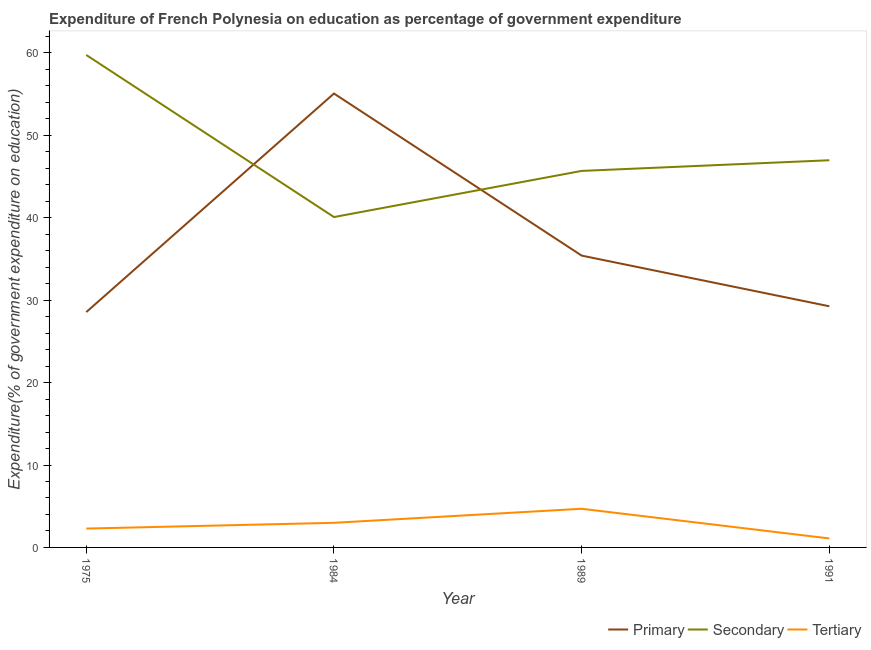What is the expenditure on secondary education in 1989?
Provide a short and direct response. 45.69. Across all years, what is the maximum expenditure on primary education?
Provide a short and direct response. 55.08. Across all years, what is the minimum expenditure on tertiary education?
Your answer should be very brief. 1.09. What is the total expenditure on primary education in the graph?
Your response must be concise. 148.32. What is the difference between the expenditure on tertiary education in 1975 and that in 1984?
Provide a short and direct response. -0.7. What is the difference between the expenditure on secondary education in 1984 and the expenditure on tertiary education in 1975?
Ensure brevity in your answer.  37.8. What is the average expenditure on secondary education per year?
Offer a very short reply. 48.13. In the year 1989, what is the difference between the expenditure on primary education and expenditure on secondary education?
Your answer should be very brief. -10.28. What is the ratio of the expenditure on primary education in 1989 to that in 1991?
Keep it short and to the point. 1.21. Is the expenditure on secondary education in 1984 less than that in 1991?
Keep it short and to the point. Yes. Is the difference between the expenditure on tertiary education in 1989 and 1991 greater than the difference between the expenditure on primary education in 1989 and 1991?
Keep it short and to the point. No. What is the difference between the highest and the second highest expenditure on primary education?
Offer a terse response. 19.67. What is the difference between the highest and the lowest expenditure on primary education?
Ensure brevity in your answer.  26.52. In how many years, is the expenditure on tertiary education greater than the average expenditure on tertiary education taken over all years?
Give a very brief answer. 2. Is the sum of the expenditure on secondary education in 1984 and 1991 greater than the maximum expenditure on primary education across all years?
Provide a succinct answer. Yes. Is it the case that in every year, the sum of the expenditure on primary education and expenditure on secondary education is greater than the expenditure on tertiary education?
Your response must be concise. Yes. How many lines are there?
Offer a very short reply. 3. How many years are there in the graph?
Give a very brief answer. 4. What is the difference between two consecutive major ticks on the Y-axis?
Offer a terse response. 10. Are the values on the major ticks of Y-axis written in scientific E-notation?
Keep it short and to the point. No. Does the graph contain any zero values?
Your answer should be compact. No. Does the graph contain grids?
Offer a very short reply. No. What is the title of the graph?
Give a very brief answer. Expenditure of French Polynesia on education as percentage of government expenditure. What is the label or title of the X-axis?
Provide a succinct answer. Year. What is the label or title of the Y-axis?
Provide a short and direct response. Expenditure(% of government expenditure on education). What is the Expenditure(% of government expenditure on education) in Primary in 1975?
Give a very brief answer. 28.56. What is the Expenditure(% of government expenditure on education) in Secondary in 1975?
Keep it short and to the point. 59.76. What is the Expenditure(% of government expenditure on education) of Tertiary in 1975?
Keep it short and to the point. 2.29. What is the Expenditure(% of government expenditure on education) of Primary in 1984?
Your answer should be very brief. 55.08. What is the Expenditure(% of government expenditure on education) of Secondary in 1984?
Your answer should be very brief. 40.09. What is the Expenditure(% of government expenditure on education) in Tertiary in 1984?
Provide a short and direct response. 2.99. What is the Expenditure(% of government expenditure on education) of Primary in 1989?
Make the answer very short. 35.41. What is the Expenditure(% of government expenditure on education) of Secondary in 1989?
Your response must be concise. 45.69. What is the Expenditure(% of government expenditure on education) of Tertiary in 1989?
Your answer should be compact. 4.69. What is the Expenditure(% of government expenditure on education) in Primary in 1991?
Give a very brief answer. 29.26. What is the Expenditure(% of government expenditure on education) of Secondary in 1991?
Your response must be concise. 46.98. What is the Expenditure(% of government expenditure on education) in Tertiary in 1991?
Your answer should be very brief. 1.09. Across all years, what is the maximum Expenditure(% of government expenditure on education) of Primary?
Provide a succinct answer. 55.08. Across all years, what is the maximum Expenditure(% of government expenditure on education) in Secondary?
Ensure brevity in your answer.  59.76. Across all years, what is the maximum Expenditure(% of government expenditure on education) in Tertiary?
Provide a short and direct response. 4.69. Across all years, what is the minimum Expenditure(% of government expenditure on education) of Primary?
Your response must be concise. 28.56. Across all years, what is the minimum Expenditure(% of government expenditure on education) in Secondary?
Your answer should be very brief. 40.09. Across all years, what is the minimum Expenditure(% of government expenditure on education) of Tertiary?
Your answer should be very brief. 1.09. What is the total Expenditure(% of government expenditure on education) in Primary in the graph?
Keep it short and to the point. 148.32. What is the total Expenditure(% of government expenditure on education) in Secondary in the graph?
Offer a terse response. 192.52. What is the total Expenditure(% of government expenditure on education) of Tertiary in the graph?
Your response must be concise. 11.06. What is the difference between the Expenditure(% of government expenditure on education) in Primary in 1975 and that in 1984?
Make the answer very short. -26.52. What is the difference between the Expenditure(% of government expenditure on education) of Secondary in 1975 and that in 1984?
Your answer should be compact. 19.66. What is the difference between the Expenditure(% of government expenditure on education) of Tertiary in 1975 and that in 1984?
Provide a succinct answer. -0.7. What is the difference between the Expenditure(% of government expenditure on education) in Primary in 1975 and that in 1989?
Offer a terse response. -6.85. What is the difference between the Expenditure(% of government expenditure on education) in Secondary in 1975 and that in 1989?
Provide a short and direct response. 14.07. What is the difference between the Expenditure(% of government expenditure on education) in Tertiary in 1975 and that in 1989?
Make the answer very short. -2.4. What is the difference between the Expenditure(% of government expenditure on education) of Primary in 1975 and that in 1991?
Offer a very short reply. -0.7. What is the difference between the Expenditure(% of government expenditure on education) in Secondary in 1975 and that in 1991?
Provide a short and direct response. 12.77. What is the difference between the Expenditure(% of government expenditure on education) of Tertiary in 1975 and that in 1991?
Provide a short and direct response. 1.2. What is the difference between the Expenditure(% of government expenditure on education) in Primary in 1984 and that in 1989?
Your response must be concise. 19.67. What is the difference between the Expenditure(% of government expenditure on education) of Secondary in 1984 and that in 1989?
Your answer should be very brief. -5.6. What is the difference between the Expenditure(% of government expenditure on education) of Tertiary in 1984 and that in 1989?
Your answer should be compact. -1.7. What is the difference between the Expenditure(% of government expenditure on education) in Primary in 1984 and that in 1991?
Your answer should be very brief. 25.82. What is the difference between the Expenditure(% of government expenditure on education) of Secondary in 1984 and that in 1991?
Give a very brief answer. -6.89. What is the difference between the Expenditure(% of government expenditure on education) of Tertiary in 1984 and that in 1991?
Your response must be concise. 1.9. What is the difference between the Expenditure(% of government expenditure on education) in Primary in 1989 and that in 1991?
Offer a very short reply. 6.15. What is the difference between the Expenditure(% of government expenditure on education) in Secondary in 1989 and that in 1991?
Make the answer very short. -1.29. What is the difference between the Expenditure(% of government expenditure on education) in Tertiary in 1989 and that in 1991?
Provide a succinct answer. 3.6. What is the difference between the Expenditure(% of government expenditure on education) in Primary in 1975 and the Expenditure(% of government expenditure on education) in Secondary in 1984?
Provide a short and direct response. -11.53. What is the difference between the Expenditure(% of government expenditure on education) of Primary in 1975 and the Expenditure(% of government expenditure on education) of Tertiary in 1984?
Your answer should be very brief. 25.57. What is the difference between the Expenditure(% of government expenditure on education) of Secondary in 1975 and the Expenditure(% of government expenditure on education) of Tertiary in 1984?
Your response must be concise. 56.77. What is the difference between the Expenditure(% of government expenditure on education) of Primary in 1975 and the Expenditure(% of government expenditure on education) of Secondary in 1989?
Give a very brief answer. -17.13. What is the difference between the Expenditure(% of government expenditure on education) in Primary in 1975 and the Expenditure(% of government expenditure on education) in Tertiary in 1989?
Offer a very short reply. 23.87. What is the difference between the Expenditure(% of government expenditure on education) in Secondary in 1975 and the Expenditure(% of government expenditure on education) in Tertiary in 1989?
Make the answer very short. 55.07. What is the difference between the Expenditure(% of government expenditure on education) of Primary in 1975 and the Expenditure(% of government expenditure on education) of Secondary in 1991?
Your answer should be very brief. -18.42. What is the difference between the Expenditure(% of government expenditure on education) of Primary in 1975 and the Expenditure(% of government expenditure on education) of Tertiary in 1991?
Offer a terse response. 27.47. What is the difference between the Expenditure(% of government expenditure on education) in Secondary in 1975 and the Expenditure(% of government expenditure on education) in Tertiary in 1991?
Your answer should be compact. 58.67. What is the difference between the Expenditure(% of government expenditure on education) in Primary in 1984 and the Expenditure(% of government expenditure on education) in Secondary in 1989?
Your answer should be very brief. 9.39. What is the difference between the Expenditure(% of government expenditure on education) in Primary in 1984 and the Expenditure(% of government expenditure on education) in Tertiary in 1989?
Your answer should be compact. 50.39. What is the difference between the Expenditure(% of government expenditure on education) of Secondary in 1984 and the Expenditure(% of government expenditure on education) of Tertiary in 1989?
Ensure brevity in your answer.  35.4. What is the difference between the Expenditure(% of government expenditure on education) of Primary in 1984 and the Expenditure(% of government expenditure on education) of Secondary in 1991?
Make the answer very short. 8.1. What is the difference between the Expenditure(% of government expenditure on education) in Primary in 1984 and the Expenditure(% of government expenditure on education) in Tertiary in 1991?
Offer a very short reply. 53.99. What is the difference between the Expenditure(% of government expenditure on education) of Secondary in 1984 and the Expenditure(% of government expenditure on education) of Tertiary in 1991?
Offer a terse response. 39. What is the difference between the Expenditure(% of government expenditure on education) in Primary in 1989 and the Expenditure(% of government expenditure on education) in Secondary in 1991?
Offer a terse response. -11.57. What is the difference between the Expenditure(% of government expenditure on education) of Primary in 1989 and the Expenditure(% of government expenditure on education) of Tertiary in 1991?
Offer a terse response. 34.32. What is the difference between the Expenditure(% of government expenditure on education) of Secondary in 1989 and the Expenditure(% of government expenditure on education) of Tertiary in 1991?
Keep it short and to the point. 44.6. What is the average Expenditure(% of government expenditure on education) in Primary per year?
Keep it short and to the point. 37.08. What is the average Expenditure(% of government expenditure on education) of Secondary per year?
Ensure brevity in your answer.  48.13. What is the average Expenditure(% of government expenditure on education) of Tertiary per year?
Your answer should be very brief. 2.76. In the year 1975, what is the difference between the Expenditure(% of government expenditure on education) in Primary and Expenditure(% of government expenditure on education) in Secondary?
Offer a very short reply. -31.2. In the year 1975, what is the difference between the Expenditure(% of government expenditure on education) in Primary and Expenditure(% of government expenditure on education) in Tertiary?
Your answer should be compact. 26.27. In the year 1975, what is the difference between the Expenditure(% of government expenditure on education) in Secondary and Expenditure(% of government expenditure on education) in Tertiary?
Offer a very short reply. 57.47. In the year 1984, what is the difference between the Expenditure(% of government expenditure on education) of Primary and Expenditure(% of government expenditure on education) of Secondary?
Ensure brevity in your answer.  14.99. In the year 1984, what is the difference between the Expenditure(% of government expenditure on education) of Primary and Expenditure(% of government expenditure on education) of Tertiary?
Provide a succinct answer. 52.09. In the year 1984, what is the difference between the Expenditure(% of government expenditure on education) of Secondary and Expenditure(% of government expenditure on education) of Tertiary?
Give a very brief answer. 37.1. In the year 1989, what is the difference between the Expenditure(% of government expenditure on education) in Primary and Expenditure(% of government expenditure on education) in Secondary?
Ensure brevity in your answer.  -10.28. In the year 1989, what is the difference between the Expenditure(% of government expenditure on education) in Primary and Expenditure(% of government expenditure on education) in Tertiary?
Keep it short and to the point. 30.72. In the year 1989, what is the difference between the Expenditure(% of government expenditure on education) in Secondary and Expenditure(% of government expenditure on education) in Tertiary?
Offer a very short reply. 41. In the year 1991, what is the difference between the Expenditure(% of government expenditure on education) of Primary and Expenditure(% of government expenditure on education) of Secondary?
Offer a very short reply. -17.72. In the year 1991, what is the difference between the Expenditure(% of government expenditure on education) in Primary and Expenditure(% of government expenditure on education) in Tertiary?
Your answer should be very brief. 28.17. In the year 1991, what is the difference between the Expenditure(% of government expenditure on education) in Secondary and Expenditure(% of government expenditure on education) in Tertiary?
Offer a very short reply. 45.89. What is the ratio of the Expenditure(% of government expenditure on education) of Primary in 1975 to that in 1984?
Make the answer very short. 0.52. What is the ratio of the Expenditure(% of government expenditure on education) in Secondary in 1975 to that in 1984?
Your answer should be very brief. 1.49. What is the ratio of the Expenditure(% of government expenditure on education) of Tertiary in 1975 to that in 1984?
Provide a succinct answer. 0.77. What is the ratio of the Expenditure(% of government expenditure on education) in Primary in 1975 to that in 1989?
Provide a succinct answer. 0.81. What is the ratio of the Expenditure(% of government expenditure on education) in Secondary in 1975 to that in 1989?
Offer a very short reply. 1.31. What is the ratio of the Expenditure(% of government expenditure on education) in Tertiary in 1975 to that in 1989?
Your answer should be compact. 0.49. What is the ratio of the Expenditure(% of government expenditure on education) in Secondary in 1975 to that in 1991?
Give a very brief answer. 1.27. What is the ratio of the Expenditure(% of government expenditure on education) in Tertiary in 1975 to that in 1991?
Your answer should be compact. 2.1. What is the ratio of the Expenditure(% of government expenditure on education) in Primary in 1984 to that in 1989?
Offer a very short reply. 1.56. What is the ratio of the Expenditure(% of government expenditure on education) of Secondary in 1984 to that in 1989?
Your response must be concise. 0.88. What is the ratio of the Expenditure(% of government expenditure on education) of Tertiary in 1984 to that in 1989?
Offer a very short reply. 0.64. What is the ratio of the Expenditure(% of government expenditure on education) of Primary in 1984 to that in 1991?
Offer a very short reply. 1.88. What is the ratio of the Expenditure(% of government expenditure on education) of Secondary in 1984 to that in 1991?
Give a very brief answer. 0.85. What is the ratio of the Expenditure(% of government expenditure on education) of Tertiary in 1984 to that in 1991?
Offer a terse response. 2.74. What is the ratio of the Expenditure(% of government expenditure on education) in Primary in 1989 to that in 1991?
Keep it short and to the point. 1.21. What is the ratio of the Expenditure(% of government expenditure on education) in Secondary in 1989 to that in 1991?
Offer a very short reply. 0.97. What is the ratio of the Expenditure(% of government expenditure on education) of Tertiary in 1989 to that in 1991?
Keep it short and to the point. 4.3. What is the difference between the highest and the second highest Expenditure(% of government expenditure on education) in Primary?
Offer a very short reply. 19.67. What is the difference between the highest and the second highest Expenditure(% of government expenditure on education) of Secondary?
Ensure brevity in your answer.  12.77. What is the difference between the highest and the second highest Expenditure(% of government expenditure on education) of Tertiary?
Offer a terse response. 1.7. What is the difference between the highest and the lowest Expenditure(% of government expenditure on education) in Primary?
Provide a succinct answer. 26.52. What is the difference between the highest and the lowest Expenditure(% of government expenditure on education) of Secondary?
Your answer should be very brief. 19.66. What is the difference between the highest and the lowest Expenditure(% of government expenditure on education) of Tertiary?
Keep it short and to the point. 3.6. 